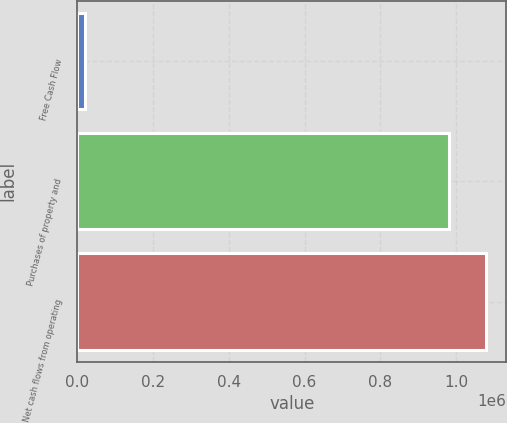<chart> <loc_0><loc_0><loc_500><loc_500><bar_chart><fcel>Free Cash Flow<fcel>Purchases of property and<fcel>Net cash flows from operating<nl><fcel>20855<fcel>980587<fcel>1.07865e+06<nl></chart> 